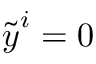<formula> <loc_0><loc_0><loc_500><loc_500>\widetilde { \boldsymbol y } ^ { i } = 0</formula> 